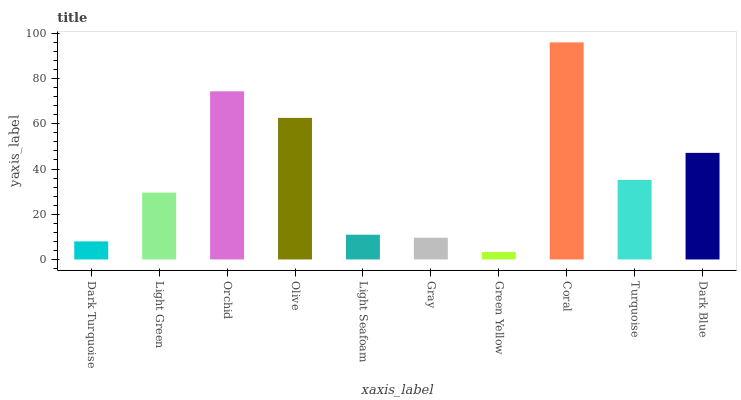Is Green Yellow the minimum?
Answer yes or no. Yes. Is Coral the maximum?
Answer yes or no. Yes. Is Light Green the minimum?
Answer yes or no. No. Is Light Green the maximum?
Answer yes or no. No. Is Light Green greater than Dark Turquoise?
Answer yes or no. Yes. Is Dark Turquoise less than Light Green?
Answer yes or no. Yes. Is Dark Turquoise greater than Light Green?
Answer yes or no. No. Is Light Green less than Dark Turquoise?
Answer yes or no. No. Is Turquoise the high median?
Answer yes or no. Yes. Is Light Green the low median?
Answer yes or no. Yes. Is Gray the high median?
Answer yes or no. No. Is Coral the low median?
Answer yes or no. No. 